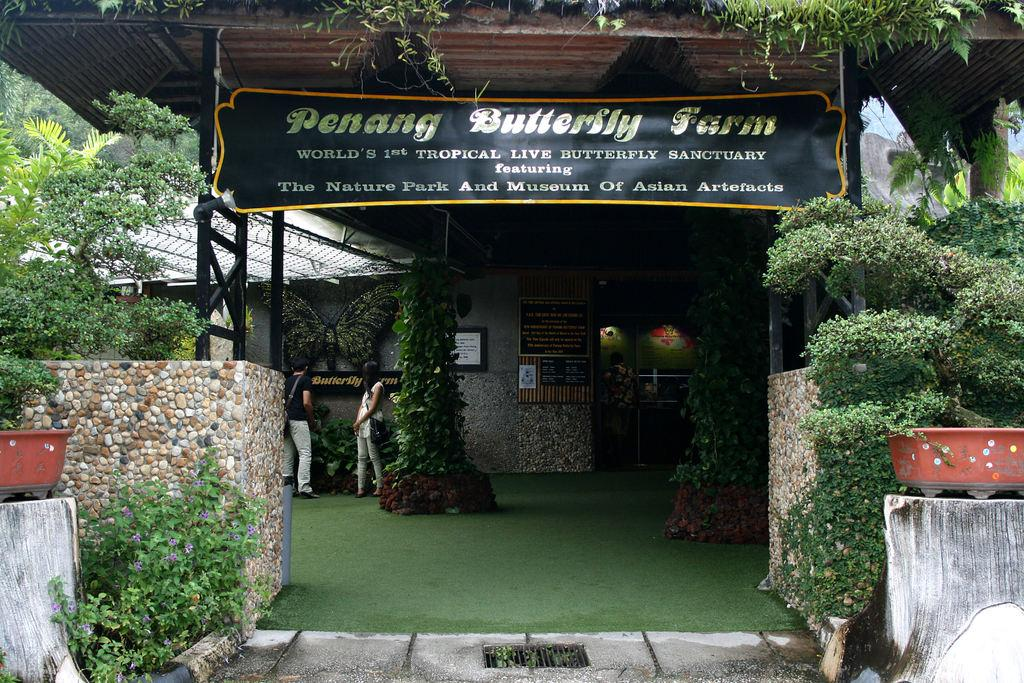What can be seen on the ground in the image? There are people on the ground in the image. What type of plants are visible in the image? There are house plants and trees in the image. What type of structure is present in the image? There are boards and a roof in the image. Can you describe any other objects in the image? There are some unspecified objects in the image. What type of sign can be seen on the stomach of the person in the image? There is no sign visible on the stomach of any person in the image. What type of pet is present in the image? There is no pet present in the image. 